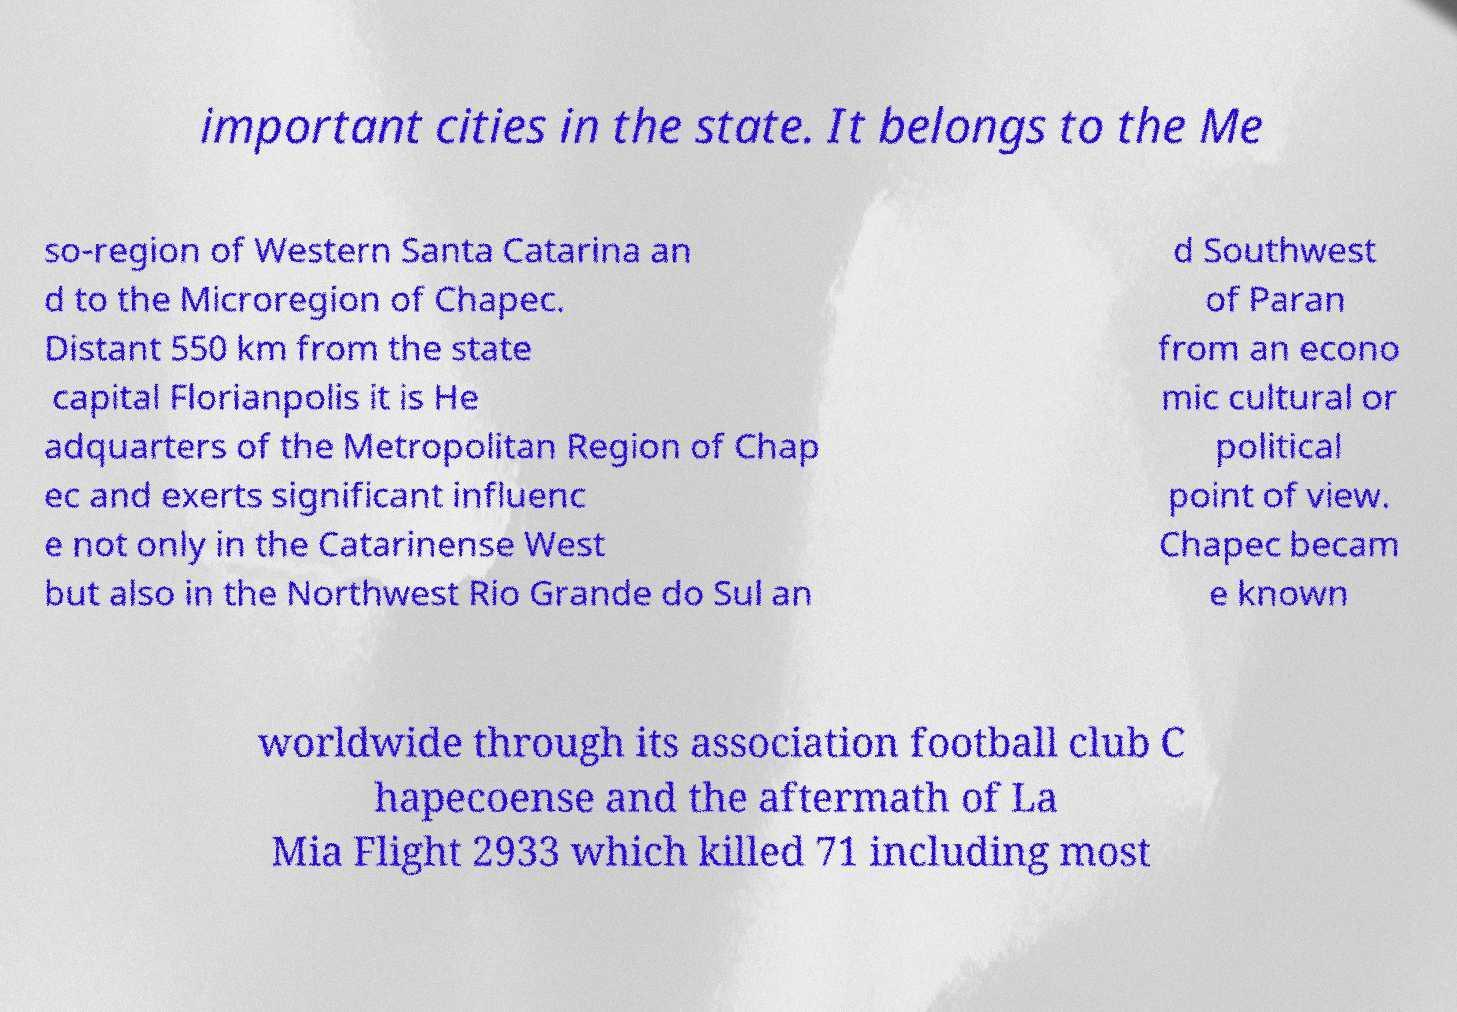Could you assist in decoding the text presented in this image and type it out clearly? important cities in the state. It belongs to the Me so-region of Western Santa Catarina an d to the Microregion of Chapec. Distant 550 km from the state capital Florianpolis it is He adquarters of the Metropolitan Region of Chap ec and exerts significant influenc e not only in the Catarinense West but also in the Northwest Rio Grande do Sul an d Southwest of Paran from an econo mic cultural or political point of view. Chapec becam e known worldwide through its association football club C hapecoense and the aftermath of La Mia Flight 2933 which killed 71 including most 